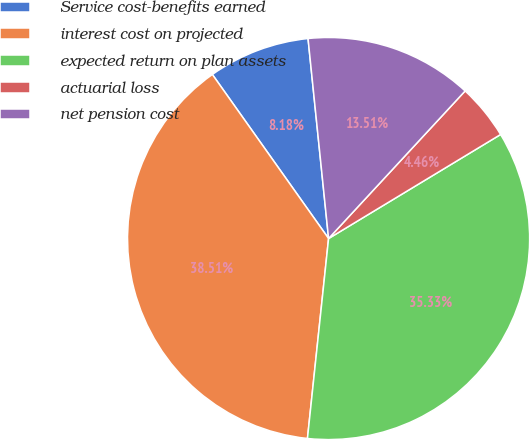<chart> <loc_0><loc_0><loc_500><loc_500><pie_chart><fcel>Service cost-benefits earned<fcel>interest cost on projected<fcel>expected return on plan assets<fcel>actuarial loss<fcel>net pension cost<nl><fcel>8.18%<fcel>38.51%<fcel>35.33%<fcel>4.46%<fcel>13.51%<nl></chart> 